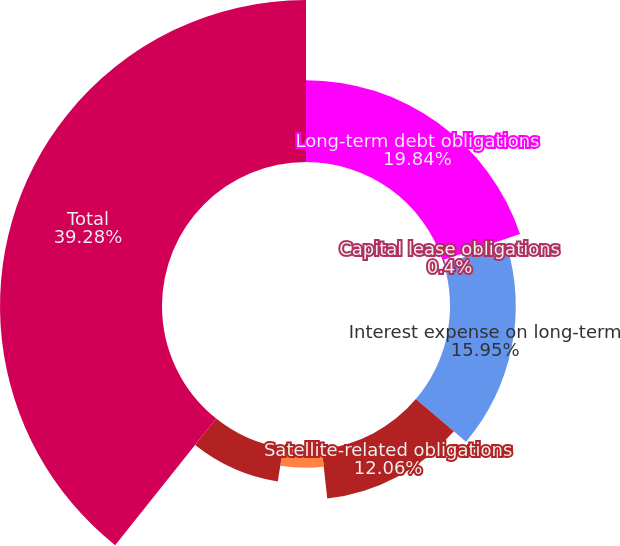<chart> <loc_0><loc_0><loc_500><loc_500><pie_chart><fcel>Long-term debt obligations<fcel>Capital lease obligations<fcel>Interest expense on long-term<fcel>Satellite-related obligations<fcel>Operating lease obligations<fcel>Purchase obligations<fcel>Total<nl><fcel>19.84%<fcel>0.4%<fcel>15.95%<fcel>12.06%<fcel>4.29%<fcel>8.18%<fcel>39.28%<nl></chart> 